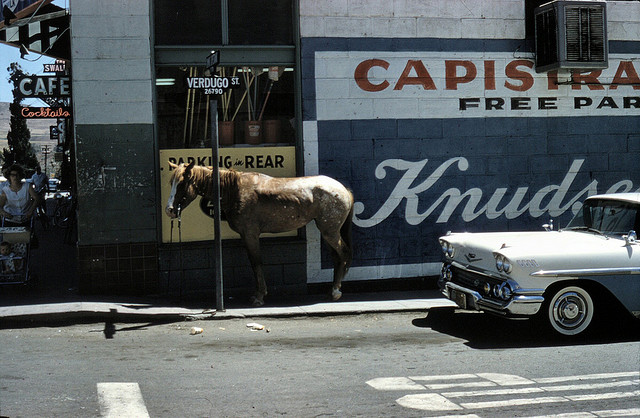Please extract the text content from this image. SWAL CAFE VERDUGO ST 26390 RADKING in REAR CAPISTRA FREE PAR Knudse OP 